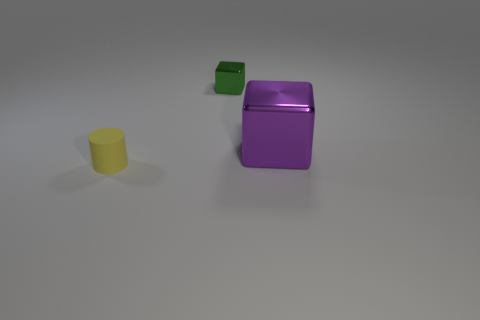Are there any other things that have the same size as the purple shiny block?
Your response must be concise. No. Are there any metal things that have the same size as the purple shiny block?
Ensure brevity in your answer.  No. There is a metallic thing that is behind the large object; how big is it?
Keep it short and to the point. Small. There is a metallic block that is on the right side of the green metal object; are there any shiny cubes on the left side of it?
Give a very brief answer. Yes. How many other things are there of the same shape as the small rubber object?
Offer a terse response. 0. Is the big purple thing the same shape as the small yellow object?
Your answer should be compact. No. The thing that is on the left side of the large object and in front of the tiny green metallic object is what color?
Make the answer very short. Yellow. How many small things are either green cubes or purple cubes?
Keep it short and to the point. 1. Are there any other things of the same color as the small matte object?
Provide a short and direct response. No. What material is the small object to the right of the small object in front of the object that is to the right of the small metal thing made of?
Give a very brief answer. Metal. 